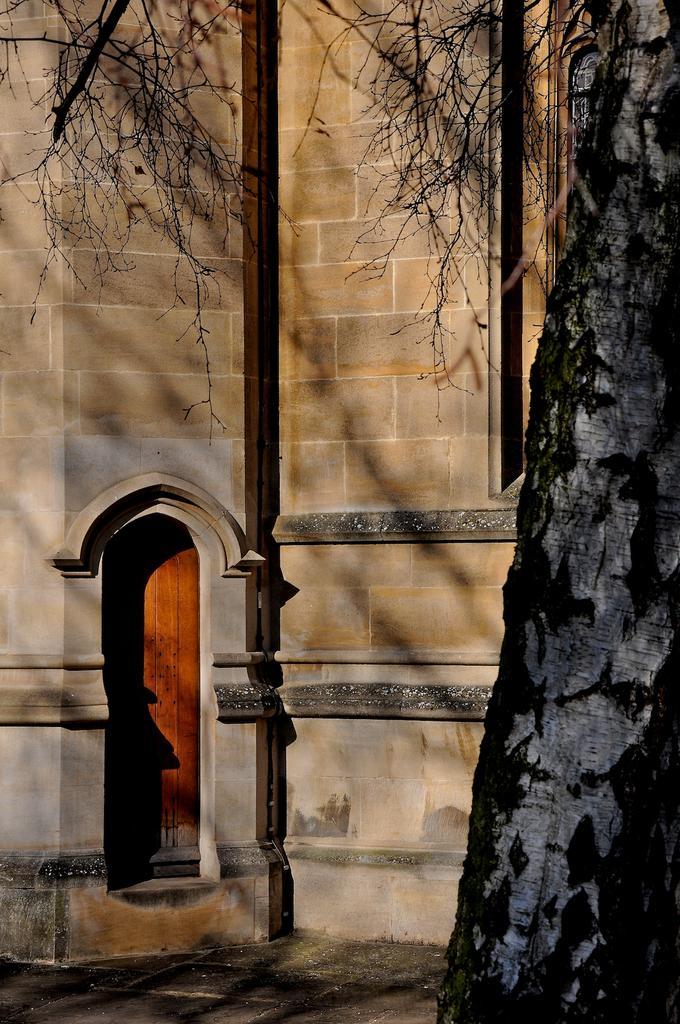How would you summarize this image in a sentence or two? On the right there is a tree. In the background there is a building and there is a door. 